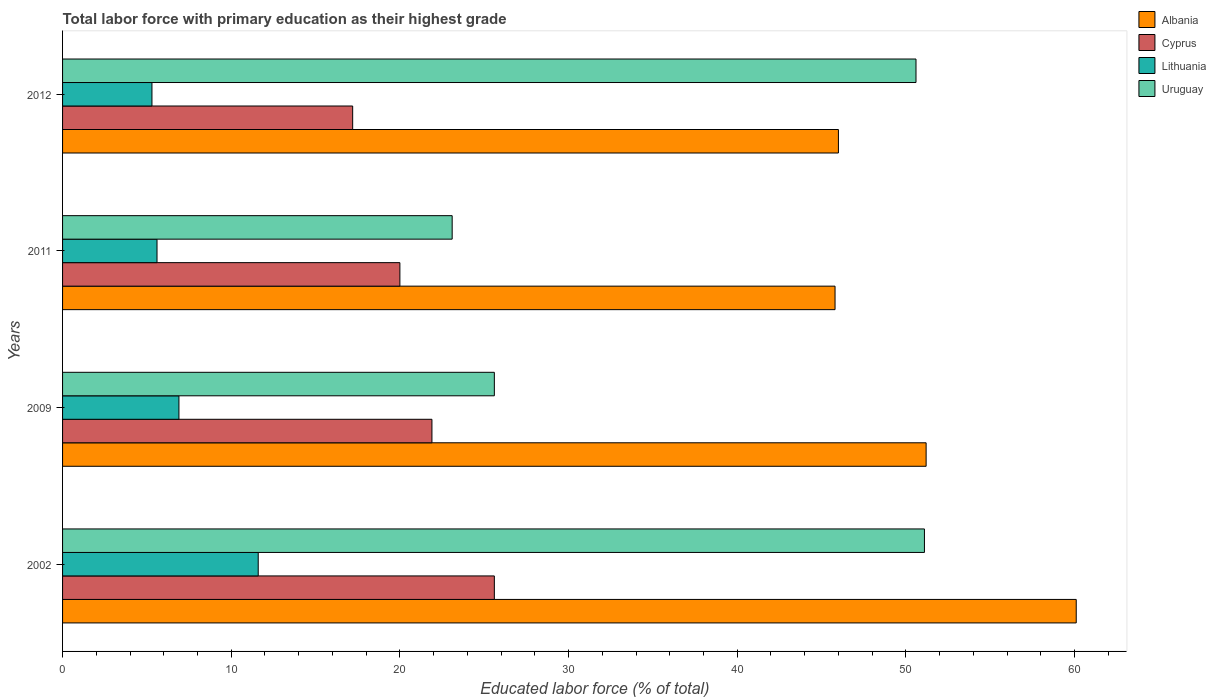How many groups of bars are there?
Provide a short and direct response. 4. Are the number of bars on each tick of the Y-axis equal?
Provide a succinct answer. Yes. How many bars are there on the 4th tick from the top?
Keep it short and to the point. 4. How many bars are there on the 2nd tick from the bottom?
Keep it short and to the point. 4. What is the percentage of total labor force with primary education in Albania in 2009?
Offer a terse response. 51.2. Across all years, what is the maximum percentage of total labor force with primary education in Cyprus?
Ensure brevity in your answer.  25.6. Across all years, what is the minimum percentage of total labor force with primary education in Cyprus?
Offer a very short reply. 17.2. What is the total percentage of total labor force with primary education in Cyprus in the graph?
Keep it short and to the point. 84.7. What is the difference between the percentage of total labor force with primary education in Cyprus in 2009 and that in 2011?
Provide a short and direct response. 1.9. What is the difference between the percentage of total labor force with primary education in Albania in 2011 and the percentage of total labor force with primary education in Cyprus in 2012?
Ensure brevity in your answer.  28.6. What is the average percentage of total labor force with primary education in Uruguay per year?
Provide a succinct answer. 37.6. In the year 2012, what is the difference between the percentage of total labor force with primary education in Uruguay and percentage of total labor force with primary education in Cyprus?
Make the answer very short. 33.4. What is the ratio of the percentage of total labor force with primary education in Cyprus in 2002 to that in 2012?
Your answer should be compact. 1.49. Is the difference between the percentage of total labor force with primary education in Uruguay in 2002 and 2012 greater than the difference between the percentage of total labor force with primary education in Cyprus in 2002 and 2012?
Keep it short and to the point. No. What is the difference between the highest and the lowest percentage of total labor force with primary education in Albania?
Keep it short and to the point. 14.3. Is it the case that in every year, the sum of the percentage of total labor force with primary education in Albania and percentage of total labor force with primary education in Uruguay is greater than the sum of percentage of total labor force with primary education in Lithuania and percentage of total labor force with primary education in Cyprus?
Your answer should be very brief. Yes. What does the 4th bar from the top in 2009 represents?
Offer a terse response. Albania. What does the 3rd bar from the bottom in 2009 represents?
Ensure brevity in your answer.  Lithuania. What is the difference between two consecutive major ticks on the X-axis?
Offer a terse response. 10. Are the values on the major ticks of X-axis written in scientific E-notation?
Ensure brevity in your answer.  No. How many legend labels are there?
Ensure brevity in your answer.  4. How are the legend labels stacked?
Ensure brevity in your answer.  Vertical. What is the title of the graph?
Ensure brevity in your answer.  Total labor force with primary education as their highest grade. What is the label or title of the X-axis?
Ensure brevity in your answer.  Educated labor force (% of total). What is the Educated labor force (% of total) of Albania in 2002?
Make the answer very short. 60.1. What is the Educated labor force (% of total) in Cyprus in 2002?
Ensure brevity in your answer.  25.6. What is the Educated labor force (% of total) of Lithuania in 2002?
Give a very brief answer. 11.6. What is the Educated labor force (% of total) in Uruguay in 2002?
Your response must be concise. 51.1. What is the Educated labor force (% of total) in Albania in 2009?
Offer a very short reply. 51.2. What is the Educated labor force (% of total) in Cyprus in 2009?
Your answer should be compact. 21.9. What is the Educated labor force (% of total) in Lithuania in 2009?
Your answer should be compact. 6.9. What is the Educated labor force (% of total) of Uruguay in 2009?
Provide a succinct answer. 25.6. What is the Educated labor force (% of total) in Albania in 2011?
Ensure brevity in your answer.  45.8. What is the Educated labor force (% of total) of Lithuania in 2011?
Your answer should be very brief. 5.6. What is the Educated labor force (% of total) in Uruguay in 2011?
Your answer should be compact. 23.1. What is the Educated labor force (% of total) in Albania in 2012?
Offer a terse response. 46. What is the Educated labor force (% of total) in Cyprus in 2012?
Offer a very short reply. 17.2. What is the Educated labor force (% of total) in Lithuania in 2012?
Offer a terse response. 5.3. What is the Educated labor force (% of total) in Uruguay in 2012?
Provide a succinct answer. 50.6. Across all years, what is the maximum Educated labor force (% of total) in Albania?
Your response must be concise. 60.1. Across all years, what is the maximum Educated labor force (% of total) of Cyprus?
Keep it short and to the point. 25.6. Across all years, what is the maximum Educated labor force (% of total) of Lithuania?
Provide a succinct answer. 11.6. Across all years, what is the maximum Educated labor force (% of total) in Uruguay?
Ensure brevity in your answer.  51.1. Across all years, what is the minimum Educated labor force (% of total) of Albania?
Provide a succinct answer. 45.8. Across all years, what is the minimum Educated labor force (% of total) of Cyprus?
Offer a terse response. 17.2. Across all years, what is the minimum Educated labor force (% of total) in Lithuania?
Your response must be concise. 5.3. Across all years, what is the minimum Educated labor force (% of total) in Uruguay?
Offer a very short reply. 23.1. What is the total Educated labor force (% of total) in Albania in the graph?
Give a very brief answer. 203.1. What is the total Educated labor force (% of total) of Cyprus in the graph?
Offer a very short reply. 84.7. What is the total Educated labor force (% of total) of Lithuania in the graph?
Your answer should be compact. 29.4. What is the total Educated labor force (% of total) in Uruguay in the graph?
Ensure brevity in your answer.  150.4. What is the difference between the Educated labor force (% of total) in Albania in 2002 and that in 2009?
Provide a short and direct response. 8.9. What is the difference between the Educated labor force (% of total) in Lithuania in 2002 and that in 2011?
Your response must be concise. 6. What is the difference between the Educated labor force (% of total) of Uruguay in 2002 and that in 2011?
Your answer should be compact. 28. What is the difference between the Educated labor force (% of total) of Lithuania in 2002 and that in 2012?
Provide a short and direct response. 6.3. What is the difference between the Educated labor force (% of total) of Albania in 2009 and that in 2011?
Provide a short and direct response. 5.4. What is the difference between the Educated labor force (% of total) in Cyprus in 2009 and that in 2011?
Make the answer very short. 1.9. What is the difference between the Educated labor force (% of total) of Lithuania in 2009 and that in 2011?
Offer a very short reply. 1.3. What is the difference between the Educated labor force (% of total) in Cyprus in 2009 and that in 2012?
Offer a very short reply. 4.7. What is the difference between the Educated labor force (% of total) of Lithuania in 2009 and that in 2012?
Offer a terse response. 1.6. What is the difference between the Educated labor force (% of total) of Uruguay in 2009 and that in 2012?
Offer a very short reply. -25. What is the difference between the Educated labor force (% of total) of Lithuania in 2011 and that in 2012?
Provide a short and direct response. 0.3. What is the difference between the Educated labor force (% of total) in Uruguay in 2011 and that in 2012?
Provide a short and direct response. -27.5. What is the difference between the Educated labor force (% of total) in Albania in 2002 and the Educated labor force (% of total) in Cyprus in 2009?
Ensure brevity in your answer.  38.2. What is the difference between the Educated labor force (% of total) of Albania in 2002 and the Educated labor force (% of total) of Lithuania in 2009?
Your answer should be very brief. 53.2. What is the difference between the Educated labor force (% of total) in Albania in 2002 and the Educated labor force (% of total) in Uruguay in 2009?
Give a very brief answer. 34.5. What is the difference between the Educated labor force (% of total) of Cyprus in 2002 and the Educated labor force (% of total) of Lithuania in 2009?
Your answer should be very brief. 18.7. What is the difference between the Educated labor force (% of total) of Cyprus in 2002 and the Educated labor force (% of total) of Uruguay in 2009?
Offer a terse response. 0. What is the difference between the Educated labor force (% of total) in Lithuania in 2002 and the Educated labor force (% of total) in Uruguay in 2009?
Give a very brief answer. -14. What is the difference between the Educated labor force (% of total) of Albania in 2002 and the Educated labor force (% of total) of Cyprus in 2011?
Offer a very short reply. 40.1. What is the difference between the Educated labor force (% of total) in Albania in 2002 and the Educated labor force (% of total) in Lithuania in 2011?
Offer a terse response. 54.5. What is the difference between the Educated labor force (% of total) in Cyprus in 2002 and the Educated labor force (% of total) in Uruguay in 2011?
Provide a succinct answer. 2.5. What is the difference between the Educated labor force (% of total) of Lithuania in 2002 and the Educated labor force (% of total) of Uruguay in 2011?
Keep it short and to the point. -11.5. What is the difference between the Educated labor force (% of total) in Albania in 2002 and the Educated labor force (% of total) in Cyprus in 2012?
Make the answer very short. 42.9. What is the difference between the Educated labor force (% of total) in Albania in 2002 and the Educated labor force (% of total) in Lithuania in 2012?
Provide a succinct answer. 54.8. What is the difference between the Educated labor force (% of total) in Cyprus in 2002 and the Educated labor force (% of total) in Lithuania in 2012?
Give a very brief answer. 20.3. What is the difference between the Educated labor force (% of total) of Lithuania in 2002 and the Educated labor force (% of total) of Uruguay in 2012?
Your answer should be very brief. -39. What is the difference between the Educated labor force (% of total) of Albania in 2009 and the Educated labor force (% of total) of Cyprus in 2011?
Provide a short and direct response. 31.2. What is the difference between the Educated labor force (% of total) in Albania in 2009 and the Educated labor force (% of total) in Lithuania in 2011?
Your answer should be very brief. 45.6. What is the difference between the Educated labor force (% of total) in Albania in 2009 and the Educated labor force (% of total) in Uruguay in 2011?
Ensure brevity in your answer.  28.1. What is the difference between the Educated labor force (% of total) in Lithuania in 2009 and the Educated labor force (% of total) in Uruguay in 2011?
Offer a terse response. -16.2. What is the difference between the Educated labor force (% of total) of Albania in 2009 and the Educated labor force (% of total) of Lithuania in 2012?
Provide a succinct answer. 45.9. What is the difference between the Educated labor force (% of total) in Albania in 2009 and the Educated labor force (% of total) in Uruguay in 2012?
Provide a succinct answer. 0.6. What is the difference between the Educated labor force (% of total) of Cyprus in 2009 and the Educated labor force (% of total) of Uruguay in 2012?
Your response must be concise. -28.7. What is the difference between the Educated labor force (% of total) of Lithuania in 2009 and the Educated labor force (% of total) of Uruguay in 2012?
Provide a short and direct response. -43.7. What is the difference between the Educated labor force (% of total) in Albania in 2011 and the Educated labor force (% of total) in Cyprus in 2012?
Give a very brief answer. 28.6. What is the difference between the Educated labor force (% of total) in Albania in 2011 and the Educated labor force (% of total) in Lithuania in 2012?
Provide a short and direct response. 40.5. What is the difference between the Educated labor force (% of total) of Albania in 2011 and the Educated labor force (% of total) of Uruguay in 2012?
Make the answer very short. -4.8. What is the difference between the Educated labor force (% of total) in Cyprus in 2011 and the Educated labor force (% of total) in Uruguay in 2012?
Your answer should be very brief. -30.6. What is the difference between the Educated labor force (% of total) of Lithuania in 2011 and the Educated labor force (% of total) of Uruguay in 2012?
Keep it short and to the point. -45. What is the average Educated labor force (% of total) in Albania per year?
Provide a short and direct response. 50.77. What is the average Educated labor force (% of total) of Cyprus per year?
Provide a succinct answer. 21.18. What is the average Educated labor force (% of total) in Lithuania per year?
Your response must be concise. 7.35. What is the average Educated labor force (% of total) of Uruguay per year?
Ensure brevity in your answer.  37.6. In the year 2002, what is the difference between the Educated labor force (% of total) in Albania and Educated labor force (% of total) in Cyprus?
Provide a short and direct response. 34.5. In the year 2002, what is the difference between the Educated labor force (% of total) in Albania and Educated labor force (% of total) in Lithuania?
Provide a short and direct response. 48.5. In the year 2002, what is the difference between the Educated labor force (% of total) of Albania and Educated labor force (% of total) of Uruguay?
Offer a terse response. 9. In the year 2002, what is the difference between the Educated labor force (% of total) in Cyprus and Educated labor force (% of total) in Uruguay?
Make the answer very short. -25.5. In the year 2002, what is the difference between the Educated labor force (% of total) of Lithuania and Educated labor force (% of total) of Uruguay?
Offer a very short reply. -39.5. In the year 2009, what is the difference between the Educated labor force (% of total) in Albania and Educated labor force (% of total) in Cyprus?
Provide a short and direct response. 29.3. In the year 2009, what is the difference between the Educated labor force (% of total) of Albania and Educated labor force (% of total) of Lithuania?
Your response must be concise. 44.3. In the year 2009, what is the difference between the Educated labor force (% of total) of Albania and Educated labor force (% of total) of Uruguay?
Offer a terse response. 25.6. In the year 2009, what is the difference between the Educated labor force (% of total) in Cyprus and Educated labor force (% of total) in Uruguay?
Your answer should be compact. -3.7. In the year 2009, what is the difference between the Educated labor force (% of total) in Lithuania and Educated labor force (% of total) in Uruguay?
Keep it short and to the point. -18.7. In the year 2011, what is the difference between the Educated labor force (% of total) in Albania and Educated labor force (% of total) in Cyprus?
Keep it short and to the point. 25.8. In the year 2011, what is the difference between the Educated labor force (% of total) in Albania and Educated labor force (% of total) in Lithuania?
Keep it short and to the point. 40.2. In the year 2011, what is the difference between the Educated labor force (% of total) of Albania and Educated labor force (% of total) of Uruguay?
Give a very brief answer. 22.7. In the year 2011, what is the difference between the Educated labor force (% of total) of Cyprus and Educated labor force (% of total) of Lithuania?
Provide a succinct answer. 14.4. In the year 2011, what is the difference between the Educated labor force (% of total) of Cyprus and Educated labor force (% of total) of Uruguay?
Your answer should be compact. -3.1. In the year 2011, what is the difference between the Educated labor force (% of total) in Lithuania and Educated labor force (% of total) in Uruguay?
Provide a short and direct response. -17.5. In the year 2012, what is the difference between the Educated labor force (% of total) of Albania and Educated labor force (% of total) of Cyprus?
Provide a succinct answer. 28.8. In the year 2012, what is the difference between the Educated labor force (% of total) in Albania and Educated labor force (% of total) in Lithuania?
Offer a very short reply. 40.7. In the year 2012, what is the difference between the Educated labor force (% of total) of Albania and Educated labor force (% of total) of Uruguay?
Provide a short and direct response. -4.6. In the year 2012, what is the difference between the Educated labor force (% of total) of Cyprus and Educated labor force (% of total) of Lithuania?
Offer a terse response. 11.9. In the year 2012, what is the difference between the Educated labor force (% of total) in Cyprus and Educated labor force (% of total) in Uruguay?
Your response must be concise. -33.4. In the year 2012, what is the difference between the Educated labor force (% of total) of Lithuania and Educated labor force (% of total) of Uruguay?
Keep it short and to the point. -45.3. What is the ratio of the Educated labor force (% of total) in Albania in 2002 to that in 2009?
Give a very brief answer. 1.17. What is the ratio of the Educated labor force (% of total) in Cyprus in 2002 to that in 2009?
Provide a succinct answer. 1.17. What is the ratio of the Educated labor force (% of total) in Lithuania in 2002 to that in 2009?
Give a very brief answer. 1.68. What is the ratio of the Educated labor force (% of total) in Uruguay in 2002 to that in 2009?
Offer a terse response. 2. What is the ratio of the Educated labor force (% of total) of Albania in 2002 to that in 2011?
Offer a very short reply. 1.31. What is the ratio of the Educated labor force (% of total) in Cyprus in 2002 to that in 2011?
Provide a succinct answer. 1.28. What is the ratio of the Educated labor force (% of total) in Lithuania in 2002 to that in 2011?
Provide a short and direct response. 2.07. What is the ratio of the Educated labor force (% of total) of Uruguay in 2002 to that in 2011?
Your answer should be very brief. 2.21. What is the ratio of the Educated labor force (% of total) of Albania in 2002 to that in 2012?
Keep it short and to the point. 1.31. What is the ratio of the Educated labor force (% of total) of Cyprus in 2002 to that in 2012?
Provide a short and direct response. 1.49. What is the ratio of the Educated labor force (% of total) in Lithuania in 2002 to that in 2012?
Give a very brief answer. 2.19. What is the ratio of the Educated labor force (% of total) in Uruguay in 2002 to that in 2012?
Your answer should be compact. 1.01. What is the ratio of the Educated labor force (% of total) in Albania in 2009 to that in 2011?
Provide a short and direct response. 1.12. What is the ratio of the Educated labor force (% of total) in Cyprus in 2009 to that in 2011?
Your answer should be compact. 1.09. What is the ratio of the Educated labor force (% of total) of Lithuania in 2009 to that in 2011?
Your answer should be compact. 1.23. What is the ratio of the Educated labor force (% of total) in Uruguay in 2009 to that in 2011?
Your answer should be very brief. 1.11. What is the ratio of the Educated labor force (% of total) of Albania in 2009 to that in 2012?
Make the answer very short. 1.11. What is the ratio of the Educated labor force (% of total) of Cyprus in 2009 to that in 2012?
Provide a succinct answer. 1.27. What is the ratio of the Educated labor force (% of total) in Lithuania in 2009 to that in 2012?
Your answer should be compact. 1.3. What is the ratio of the Educated labor force (% of total) in Uruguay in 2009 to that in 2012?
Your answer should be compact. 0.51. What is the ratio of the Educated labor force (% of total) in Cyprus in 2011 to that in 2012?
Provide a short and direct response. 1.16. What is the ratio of the Educated labor force (% of total) of Lithuania in 2011 to that in 2012?
Your answer should be very brief. 1.06. What is the ratio of the Educated labor force (% of total) in Uruguay in 2011 to that in 2012?
Your answer should be very brief. 0.46. What is the difference between the highest and the second highest Educated labor force (% of total) of Albania?
Your response must be concise. 8.9. What is the difference between the highest and the second highest Educated labor force (% of total) of Uruguay?
Ensure brevity in your answer.  0.5. What is the difference between the highest and the lowest Educated labor force (% of total) in Albania?
Give a very brief answer. 14.3. 